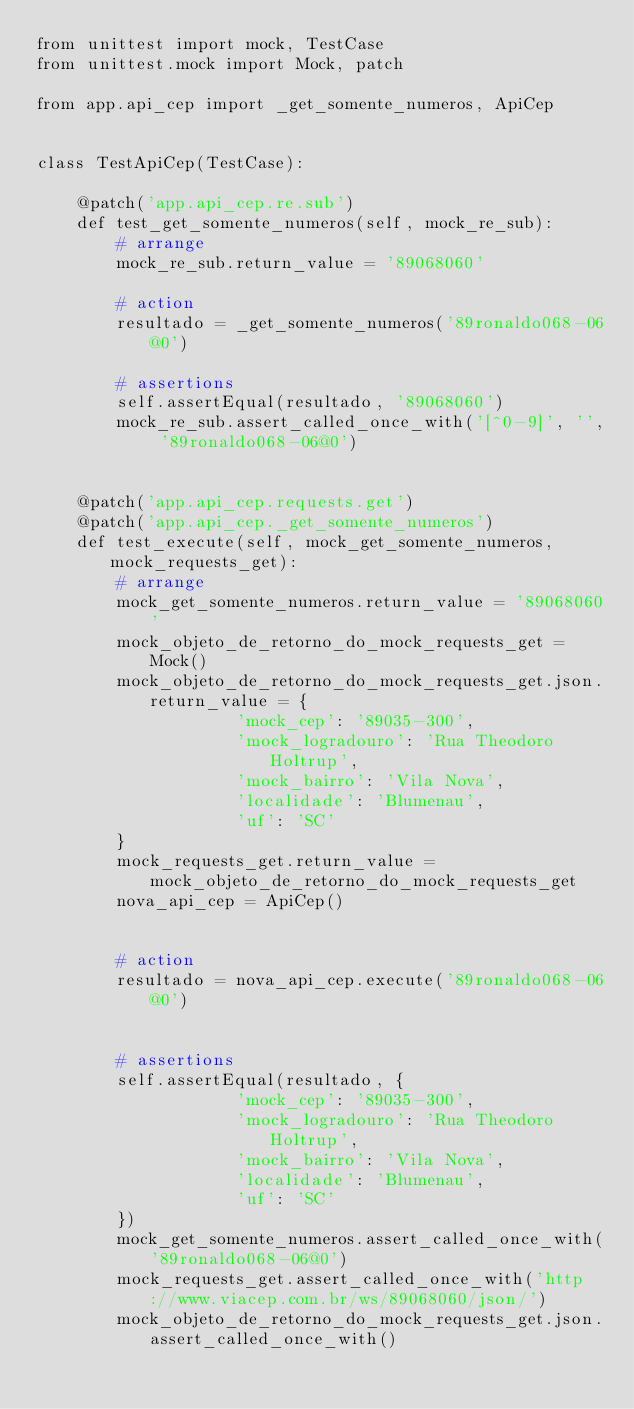<code> <loc_0><loc_0><loc_500><loc_500><_Python_>from unittest import mock, TestCase
from unittest.mock import Mock, patch

from app.api_cep import _get_somente_numeros, ApiCep


class TestApiCep(TestCase):

    @patch('app.api_cep.re.sub')
    def test_get_somente_numeros(self, mock_re_sub):
        # arrange
        mock_re_sub.return_value = '89068060'

        # action
        resultado = _get_somente_numeros('89ronaldo068-06@0')

        # assertions
        self.assertEqual(resultado, '89068060')
        mock_re_sub.assert_called_once_with('[^0-9]', '', '89ronaldo068-06@0')


    @patch('app.api_cep.requests.get')
    @patch('app.api_cep._get_somente_numeros')
    def test_execute(self, mock_get_somente_numeros, mock_requests_get):
        # arrange
        mock_get_somente_numeros.return_value = '89068060'
        mock_objeto_de_retorno_do_mock_requests_get = Mock()
        mock_objeto_de_retorno_do_mock_requests_get.json.return_value = {
                    'mock_cep': '89035-300', 
                    'mock_logradouro': 'Rua Theodoro Holtrup', 
                    'mock_bairro': 'Vila Nova', 
                    'localidade': 'Blumenau', 
                    'uf': 'SC'
        }
        mock_requests_get.return_value = mock_objeto_de_retorno_do_mock_requests_get
        nova_api_cep = ApiCep()


        # action
        resultado = nova_api_cep.execute('89ronaldo068-06@0')


        # assertions
        self.assertEqual(resultado, {
                    'mock_cep': '89035-300', 
                    'mock_logradouro': 'Rua Theodoro Holtrup', 
                    'mock_bairro': 'Vila Nova', 
                    'localidade': 'Blumenau', 
                    'uf': 'SC'
        })
        mock_get_somente_numeros.assert_called_once_with('89ronaldo068-06@0')
        mock_requests_get.assert_called_once_with('http://www.viacep.com.br/ws/89068060/json/')
        mock_objeto_de_retorno_do_mock_requests_get.json.assert_called_once_with()</code> 